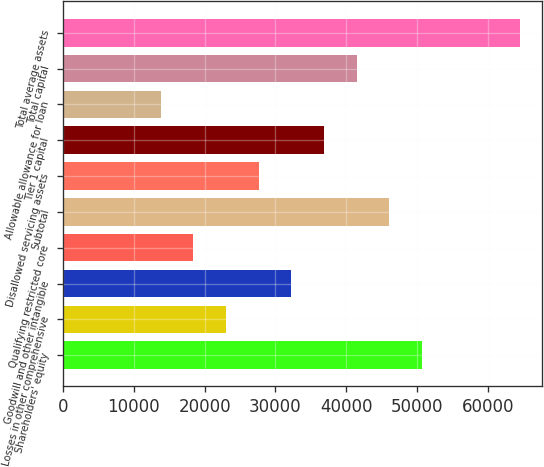Convert chart to OTSL. <chart><loc_0><loc_0><loc_500><loc_500><bar_chart><fcel>Shareholders' equity<fcel>Losses in other comprehensive<fcel>Goodwill and other intangible<fcel>Qualifying restricted core<fcel>Subtotal<fcel>Disallowed servicing assets<fcel>Tier 1 capital<fcel>Allowable allowance for loan<fcel>Total capital<fcel>Total average assets<nl><fcel>50641.6<fcel>23022.5<fcel>32228.9<fcel>18419.4<fcel>46038.4<fcel>27625.7<fcel>36832.1<fcel>13816.2<fcel>41435.2<fcel>64451.1<nl></chart> 